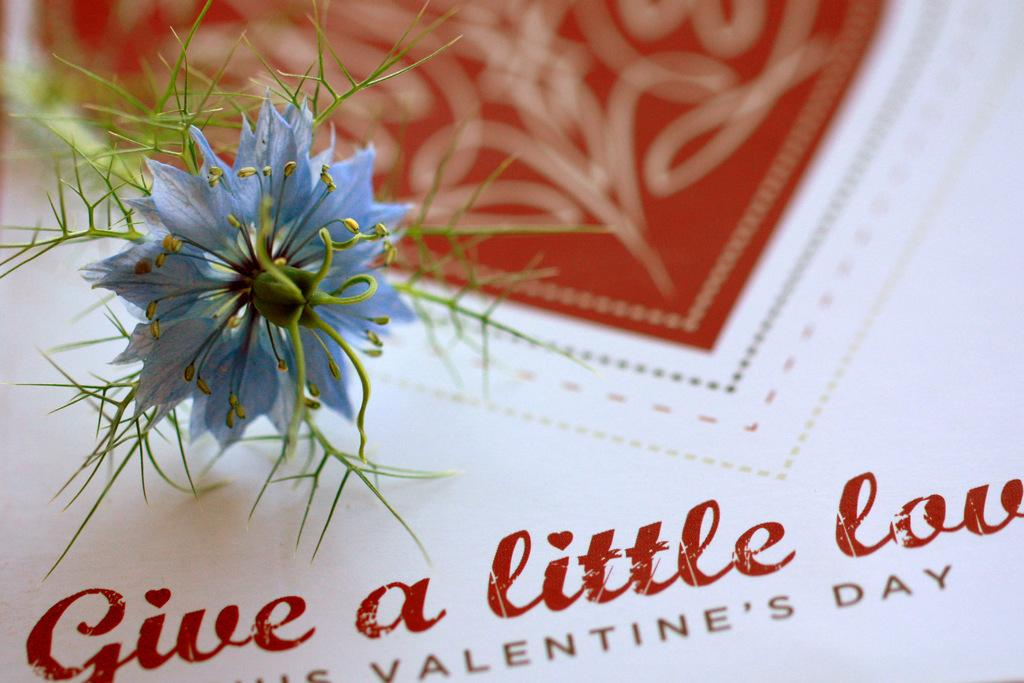What is the main subject of the image? There is a flower on a card in the image. Can you describe the flower in more detail? Unfortunately, the image does not provide enough detail to describe the flower further. What is the purpose of the card in the image? The purpose of the card is not clear from the image, but it may be a greeting card or a decorative item. How many lizards are crawling on the flower in the image? There are no lizards present in the image; it only features a flower on a card. What channel is the ladybug watching on the card in the image? There is no ladybug or television channel mentioned in the image; it only features a flower on a card. 